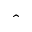Convert formula to latex. <formula><loc_0><loc_0><loc_500><loc_500>\hat { \ }</formula> 